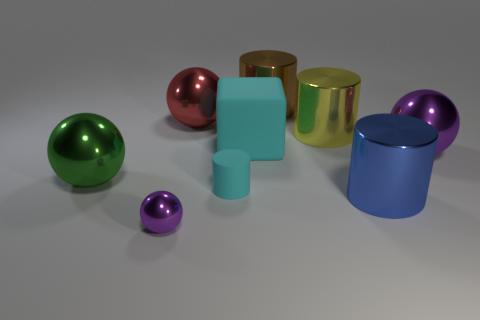How big is the purple sphere on the left side of the metal sphere that is behind the matte thing that is behind the large green thing?
Your answer should be compact. Small. Do the blue cylinder and the sphere that is on the right side of the cyan rubber cube have the same size?
Your answer should be compact. Yes. Is the number of big purple metal things behind the tiny cyan rubber cylinder less than the number of things?
Provide a short and direct response. Yes. What number of tiny cylinders are the same color as the big matte block?
Your response must be concise. 1. Are there fewer big brown metallic things than tiny blue rubber objects?
Provide a succinct answer. No. Do the green sphere and the cyan cylinder have the same material?
Offer a terse response. No. How many other things are the same size as the brown metal cylinder?
Your response must be concise. 6. There is a big thing left of the sphere in front of the large blue cylinder; what is its color?
Ensure brevity in your answer.  Green. How many other things are there of the same shape as the small shiny object?
Offer a terse response. 3. Is there a tiny purple ball that has the same material as the large blue cylinder?
Offer a terse response. Yes. 